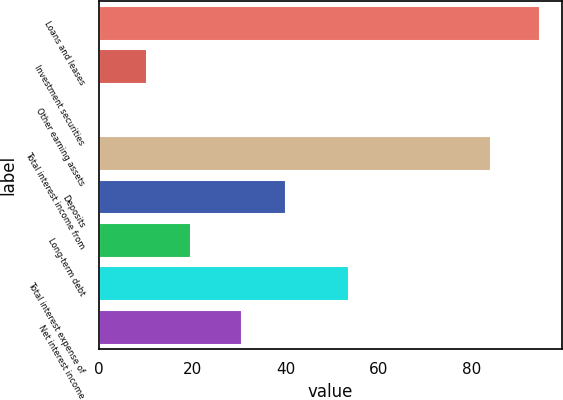Convert chart to OTSL. <chart><loc_0><loc_0><loc_500><loc_500><bar_chart><fcel>Loans and leases<fcel>Investment securities<fcel>Other earning assets<fcel>Total interest income from<fcel>Deposits<fcel>Long-term debt<fcel>Total interest expense of<fcel>Net interest income<nl><fcel>94.5<fcel>10.2<fcel>0.2<fcel>84.1<fcel>40.03<fcel>19.63<fcel>53.5<fcel>30.6<nl></chart> 